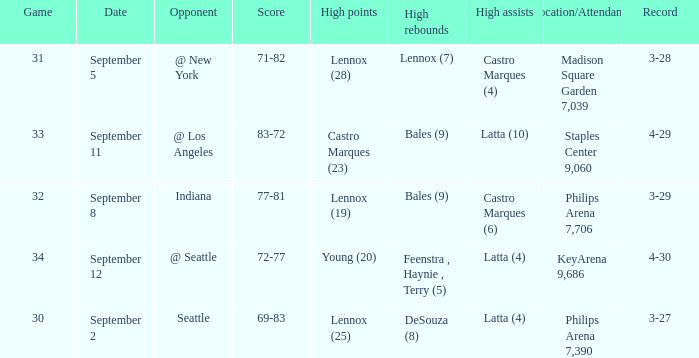When did indiana play? September 8. 